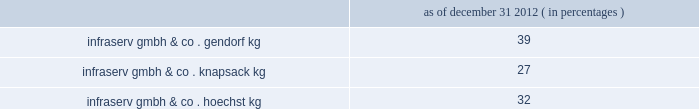Polyplastics co. , ltd .
Polyplastics is a leading supplier of engineered plastics in the asia-pacific region and is a venture between daicel chemical industries ltd. , japan ( 55% ( 55 % ) ) and ticona llc ( 45% ( 45 % ) ownership and a wholly-owned subsidiary of cna holdings llc ) .
Polyplastics is a producer and marketer of pom and lcp , with principal production facilities located in japan , taiwan , malaysia and china .
Fortron industries llc .
Fortron is a leading global producer of polyphenylene sulfide ( "pps" ) , sold under the fortron ae brand , which is used in a wide variety of automotive and other applications , especially those requiring heat and/or chemical resistance .
Fortron is a limited liability company whose members are ticona fortron inc .
( 50% ( 50 % ) ownership and a wholly-owned subsidiary of cna holdings llc ) and kureha corporation ( 50% ( 50 % ) ) .
Fortron's facility is located in wilmington , north carolina .
This venture combines the sales , marketing , distribution , compounding and manufacturing expertise of celanese with the pps polymer technology expertise of kureha .
China acetate strategic ventures .
We hold ownership interest in three separate acetate production ventures in china as follows : nantong cellulose fibers co .
Ltd .
( 31% ( 31 % ) ) , kunming cellulose fibers co .
Ltd .
( 30% ( 30 % ) ) and zhuhai cellulose fibers co .
Ltd .
( 30% ( 30 % ) ) .
The china national tobacco corporation , the chinese state-owned tobacco entity , controls the remaining ownership interest in each of these ventures .
Our chinese acetate ventures fund their operations using operating cash flow and pay a dividend in the second quarter of each fiscal year based on the ventures' performance for the preceding year .
In 2012 , 2011 and 2010 , we received cash dividends of $ 83 million , $ 78 million and $ 71 million , respectively .
During 2012 , our venture's nantong facility completed an expansion of its acetate flake and acetate tow capacity , each by 30000 tons .
We made contributions of $ 29 million over three years related to the capacity expansion in nantong .
Similar expansions since the ventures were formed have led to earnings growth and increased dividends for the company .
According to the euromonitor database services , china is estimated to have a 42% ( 42 % ) share of the world's 2011 cigarette consumption and is the fastest growing area for cigarette consumption at an estimated growth rate of 3.5% ( 3.5 % ) per year from 2011 through 2016 .
Combined , these ventures are a leader in chinese domestic acetate production and we believe we are well positioned to supply chinese cigarette producers .
Although our ownership interest in each of our china acetate ventures exceeds 20% ( 20 % ) , we account for these investments using the cost method of accounting because we determined that we cannot exercise significant influence over these entities due to local government investment in and influence over these entities , limitations on our involvement in the day-to-day operations and the present inability of the entities to provide timely financial information prepared in accordance with generally accepted accounting principles in the united states ( "us gaap" ) .
2022 other equity method investments infraservs .
We hold indirect ownership interests in several german infraserv groups that own and develop industrial parks and provide on-site general and administrative support to tenants .
Our ownership interest in the equity investments in infraserv ventures are as follows : as of december 31 , 2012 ( in percentages ) .
Raw materials and energy we purchase a variety of raw materials and energy from sources in many countries for use in our production processes .
We have a policy of maintaining , when available , multiple sources of supply for materials .
However , some of our individual plants may have single sources of supply for some of their raw materials , such as carbon monoxide , steam and acetaldehyde .
Although we have been able to obtain sufficient supplies of raw materials , there can be no assurance that unforeseen developments will not affect our raw material supply .
Even if we have multiple sources of supply for a raw material , there can be no assurance that these sources can make up for the loss of a major supplier .
It is also possible profitability will be adversely affected if we are required to qualify additional sources of supply to our specifications in the event of the loss of a sole supplier .
In addition , the price of raw materials varies , often substantially , from year to year. .
What is the percentage change in the cash dividends received by the company in 2011 compare to 2010? 
Computations: ((78 - 71) / 71)
Answer: 0.09859. 